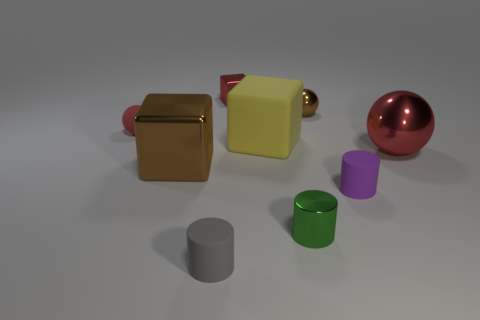Is the material of the small sphere that is right of the gray cylinder the same as the big thing that is on the left side of the tiny gray matte object? Based on the image, it appears that the material of the small sphere to the right of the gray cylinder exhibits a reflective surface similar to that of the larger spherical object to the left of the tiny gray matte object. This indicates that both spheres likely have a similar composition or finish, which is consistent with materials that have reflective properties, such as polished metal or certain types of plastic. 